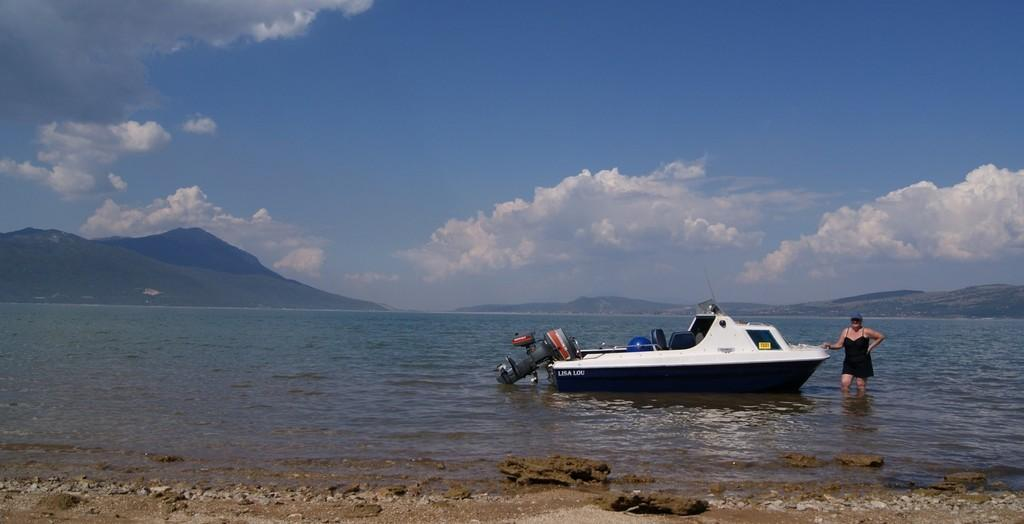What is the color of the boat in the image? The boat in the image is white. Where is the boat located? The boat is on the water. Who is standing beside the boat? There is a woman standing beside the boat. What can be seen in the background of the image? There are mountains in the background of the image. Are there any nuts hanging from the boat in the image? There are no nuts present in the image; the boat is on the water with a woman standing beside it. 